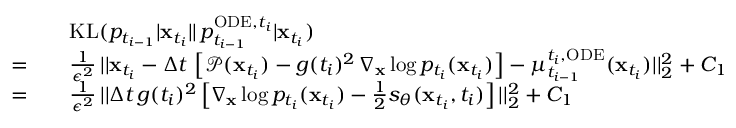<formula> <loc_0><loc_0><loc_500><loc_500>\begin{array} { r l } & { \quad K L ( p _ { t _ { i - 1 } } | x _ { t _ { i } } | | \, p _ { t _ { i - 1 } } ^ { O D E , t _ { i } } | x _ { t _ { i } } ) } \\ { = } & { \quad \frac { 1 } { \epsilon ^ { 2 } } \, | | x _ { t _ { i } } - \Delta t \, \left [ \mathcal { P } ( x _ { t _ { i } } ) - g ( t _ { i } ) ^ { 2 } \, \nabla _ { x } \log p _ { t _ { i } } ( x _ { t _ { i } } ) \right ] - \mu _ { t _ { i - 1 } } ^ { t _ { i } , O D E } ( x _ { t _ { i } } ) | | _ { 2 } ^ { 2 } + C _ { 1 } } \\ { = } & { \quad \frac { 1 } { \epsilon ^ { 2 } } \, | | \Delta t \, g ( t _ { i } ) ^ { 2 } \left [ \nabla _ { x } \log p _ { t _ { i } } ( x _ { t _ { i } } ) - \frac { 1 } { 2 } s _ { \theta } ( x _ { t _ { i } } , t _ { i } ) \right ] | | _ { 2 } ^ { 2 } + C _ { 1 } } \end{array}</formula> 